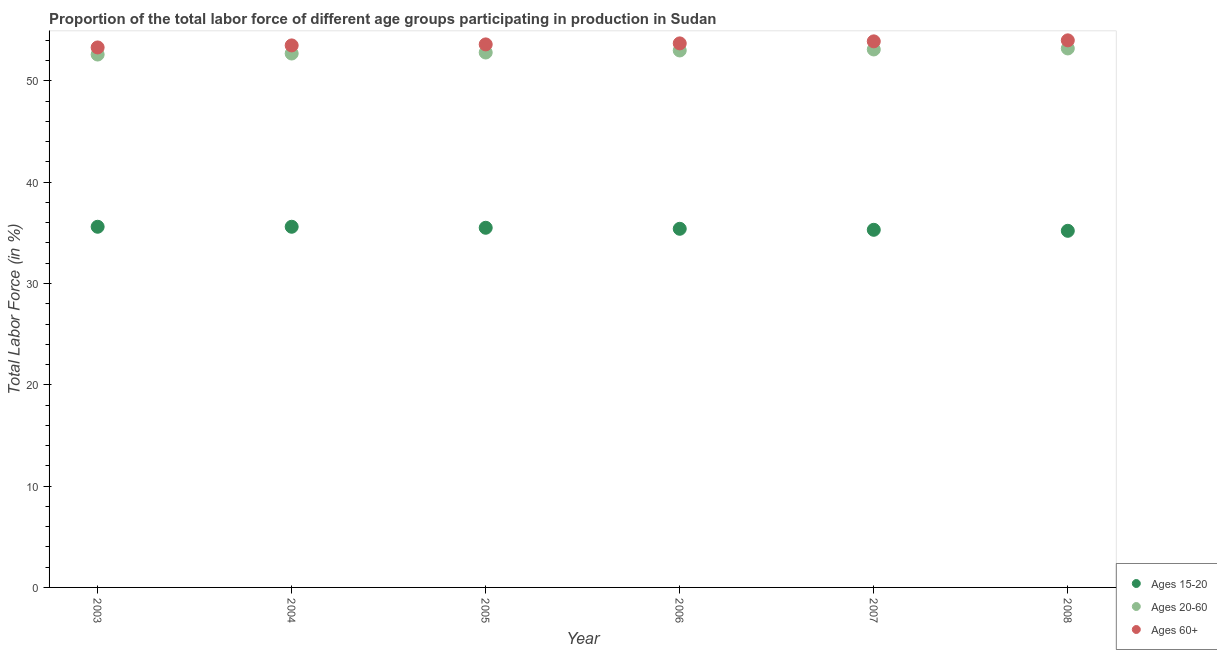Is the number of dotlines equal to the number of legend labels?
Your response must be concise. Yes. What is the percentage of labor force within the age group 15-20 in 2007?
Your answer should be compact. 35.3. Across all years, what is the maximum percentage of labor force within the age group 15-20?
Your answer should be compact. 35.6. Across all years, what is the minimum percentage of labor force above age 60?
Your answer should be very brief. 53.3. In which year was the percentage of labor force above age 60 maximum?
Give a very brief answer. 2008. What is the total percentage of labor force within the age group 20-60 in the graph?
Your response must be concise. 317.4. What is the difference between the percentage of labor force within the age group 15-20 in 2007 and that in 2008?
Make the answer very short. 0.1. What is the difference between the percentage of labor force within the age group 15-20 in 2003 and the percentage of labor force above age 60 in 2006?
Ensure brevity in your answer.  -18.1. What is the average percentage of labor force above age 60 per year?
Offer a terse response. 53.67. In the year 2008, what is the difference between the percentage of labor force above age 60 and percentage of labor force within the age group 15-20?
Offer a terse response. 18.8. In how many years, is the percentage of labor force above age 60 greater than 46 %?
Offer a very short reply. 6. What is the ratio of the percentage of labor force within the age group 15-20 in 2003 to that in 2006?
Give a very brief answer. 1.01. What is the difference between the highest and the second highest percentage of labor force within the age group 20-60?
Your answer should be very brief. 0.1. What is the difference between the highest and the lowest percentage of labor force within the age group 20-60?
Your answer should be very brief. 0.6. In how many years, is the percentage of labor force above age 60 greater than the average percentage of labor force above age 60 taken over all years?
Offer a terse response. 3. Does the percentage of labor force within the age group 15-20 monotonically increase over the years?
Your response must be concise. No. How many dotlines are there?
Keep it short and to the point. 3. How many years are there in the graph?
Your answer should be compact. 6. What is the difference between two consecutive major ticks on the Y-axis?
Offer a very short reply. 10. Are the values on the major ticks of Y-axis written in scientific E-notation?
Your answer should be compact. No. Where does the legend appear in the graph?
Give a very brief answer. Bottom right. What is the title of the graph?
Your answer should be compact. Proportion of the total labor force of different age groups participating in production in Sudan. What is the Total Labor Force (in %) of Ages 15-20 in 2003?
Offer a terse response. 35.6. What is the Total Labor Force (in %) in Ages 20-60 in 2003?
Ensure brevity in your answer.  52.6. What is the Total Labor Force (in %) of Ages 60+ in 2003?
Ensure brevity in your answer.  53.3. What is the Total Labor Force (in %) in Ages 15-20 in 2004?
Your response must be concise. 35.6. What is the Total Labor Force (in %) of Ages 20-60 in 2004?
Your answer should be compact. 52.7. What is the Total Labor Force (in %) of Ages 60+ in 2004?
Offer a very short reply. 53.5. What is the Total Labor Force (in %) in Ages 15-20 in 2005?
Provide a succinct answer. 35.5. What is the Total Labor Force (in %) of Ages 20-60 in 2005?
Give a very brief answer. 52.8. What is the Total Labor Force (in %) of Ages 60+ in 2005?
Keep it short and to the point. 53.6. What is the Total Labor Force (in %) of Ages 15-20 in 2006?
Keep it short and to the point. 35.4. What is the Total Labor Force (in %) of Ages 20-60 in 2006?
Ensure brevity in your answer.  53. What is the Total Labor Force (in %) in Ages 60+ in 2006?
Offer a very short reply. 53.7. What is the Total Labor Force (in %) of Ages 15-20 in 2007?
Your response must be concise. 35.3. What is the Total Labor Force (in %) of Ages 20-60 in 2007?
Offer a terse response. 53.1. What is the Total Labor Force (in %) of Ages 60+ in 2007?
Provide a short and direct response. 53.9. What is the Total Labor Force (in %) of Ages 15-20 in 2008?
Offer a terse response. 35.2. What is the Total Labor Force (in %) of Ages 20-60 in 2008?
Provide a succinct answer. 53.2. What is the Total Labor Force (in %) of Ages 60+ in 2008?
Give a very brief answer. 54. Across all years, what is the maximum Total Labor Force (in %) of Ages 15-20?
Ensure brevity in your answer.  35.6. Across all years, what is the maximum Total Labor Force (in %) in Ages 20-60?
Give a very brief answer. 53.2. Across all years, what is the minimum Total Labor Force (in %) in Ages 15-20?
Ensure brevity in your answer.  35.2. Across all years, what is the minimum Total Labor Force (in %) in Ages 20-60?
Keep it short and to the point. 52.6. Across all years, what is the minimum Total Labor Force (in %) in Ages 60+?
Make the answer very short. 53.3. What is the total Total Labor Force (in %) in Ages 15-20 in the graph?
Your answer should be very brief. 212.6. What is the total Total Labor Force (in %) of Ages 20-60 in the graph?
Keep it short and to the point. 317.4. What is the total Total Labor Force (in %) in Ages 60+ in the graph?
Offer a terse response. 322. What is the difference between the Total Labor Force (in %) in Ages 20-60 in 2003 and that in 2005?
Offer a terse response. -0.2. What is the difference between the Total Labor Force (in %) in Ages 60+ in 2003 and that in 2005?
Keep it short and to the point. -0.3. What is the difference between the Total Labor Force (in %) of Ages 15-20 in 2003 and that in 2006?
Offer a very short reply. 0.2. What is the difference between the Total Labor Force (in %) of Ages 15-20 in 2003 and that in 2007?
Provide a short and direct response. 0.3. What is the difference between the Total Labor Force (in %) in Ages 20-60 in 2003 and that in 2008?
Your response must be concise. -0.6. What is the difference between the Total Labor Force (in %) of Ages 15-20 in 2004 and that in 2005?
Offer a terse response. 0.1. What is the difference between the Total Labor Force (in %) in Ages 20-60 in 2004 and that in 2006?
Your response must be concise. -0.3. What is the difference between the Total Labor Force (in %) in Ages 60+ in 2004 and that in 2006?
Ensure brevity in your answer.  -0.2. What is the difference between the Total Labor Force (in %) of Ages 60+ in 2004 and that in 2007?
Give a very brief answer. -0.4. What is the difference between the Total Labor Force (in %) in Ages 60+ in 2004 and that in 2008?
Your answer should be compact. -0.5. What is the difference between the Total Labor Force (in %) of Ages 15-20 in 2005 and that in 2006?
Your response must be concise. 0.1. What is the difference between the Total Labor Force (in %) of Ages 20-60 in 2005 and that in 2006?
Provide a succinct answer. -0.2. What is the difference between the Total Labor Force (in %) in Ages 60+ in 2005 and that in 2006?
Ensure brevity in your answer.  -0.1. What is the difference between the Total Labor Force (in %) of Ages 15-20 in 2005 and that in 2007?
Provide a succinct answer. 0.2. What is the difference between the Total Labor Force (in %) of Ages 20-60 in 2005 and that in 2008?
Offer a terse response. -0.4. What is the difference between the Total Labor Force (in %) in Ages 60+ in 2005 and that in 2008?
Your answer should be very brief. -0.4. What is the difference between the Total Labor Force (in %) in Ages 20-60 in 2006 and that in 2007?
Offer a very short reply. -0.1. What is the difference between the Total Labor Force (in %) in Ages 60+ in 2006 and that in 2007?
Offer a terse response. -0.2. What is the difference between the Total Labor Force (in %) of Ages 20-60 in 2006 and that in 2008?
Give a very brief answer. -0.2. What is the difference between the Total Labor Force (in %) of Ages 60+ in 2006 and that in 2008?
Provide a succinct answer. -0.3. What is the difference between the Total Labor Force (in %) of Ages 20-60 in 2007 and that in 2008?
Offer a very short reply. -0.1. What is the difference between the Total Labor Force (in %) in Ages 60+ in 2007 and that in 2008?
Make the answer very short. -0.1. What is the difference between the Total Labor Force (in %) in Ages 15-20 in 2003 and the Total Labor Force (in %) in Ages 20-60 in 2004?
Ensure brevity in your answer.  -17.1. What is the difference between the Total Labor Force (in %) of Ages 15-20 in 2003 and the Total Labor Force (in %) of Ages 60+ in 2004?
Your answer should be compact. -17.9. What is the difference between the Total Labor Force (in %) of Ages 20-60 in 2003 and the Total Labor Force (in %) of Ages 60+ in 2004?
Your answer should be very brief. -0.9. What is the difference between the Total Labor Force (in %) in Ages 15-20 in 2003 and the Total Labor Force (in %) in Ages 20-60 in 2005?
Provide a short and direct response. -17.2. What is the difference between the Total Labor Force (in %) of Ages 15-20 in 2003 and the Total Labor Force (in %) of Ages 60+ in 2005?
Ensure brevity in your answer.  -18. What is the difference between the Total Labor Force (in %) of Ages 20-60 in 2003 and the Total Labor Force (in %) of Ages 60+ in 2005?
Your response must be concise. -1. What is the difference between the Total Labor Force (in %) of Ages 15-20 in 2003 and the Total Labor Force (in %) of Ages 20-60 in 2006?
Your answer should be very brief. -17.4. What is the difference between the Total Labor Force (in %) in Ages 15-20 in 2003 and the Total Labor Force (in %) in Ages 60+ in 2006?
Offer a terse response. -18.1. What is the difference between the Total Labor Force (in %) of Ages 15-20 in 2003 and the Total Labor Force (in %) of Ages 20-60 in 2007?
Ensure brevity in your answer.  -17.5. What is the difference between the Total Labor Force (in %) in Ages 15-20 in 2003 and the Total Labor Force (in %) in Ages 60+ in 2007?
Offer a very short reply. -18.3. What is the difference between the Total Labor Force (in %) of Ages 15-20 in 2003 and the Total Labor Force (in %) of Ages 20-60 in 2008?
Give a very brief answer. -17.6. What is the difference between the Total Labor Force (in %) in Ages 15-20 in 2003 and the Total Labor Force (in %) in Ages 60+ in 2008?
Provide a short and direct response. -18.4. What is the difference between the Total Labor Force (in %) of Ages 15-20 in 2004 and the Total Labor Force (in %) of Ages 20-60 in 2005?
Offer a very short reply. -17.2. What is the difference between the Total Labor Force (in %) of Ages 15-20 in 2004 and the Total Labor Force (in %) of Ages 60+ in 2005?
Your answer should be very brief. -18. What is the difference between the Total Labor Force (in %) of Ages 20-60 in 2004 and the Total Labor Force (in %) of Ages 60+ in 2005?
Offer a very short reply. -0.9. What is the difference between the Total Labor Force (in %) of Ages 15-20 in 2004 and the Total Labor Force (in %) of Ages 20-60 in 2006?
Offer a terse response. -17.4. What is the difference between the Total Labor Force (in %) in Ages 15-20 in 2004 and the Total Labor Force (in %) in Ages 60+ in 2006?
Keep it short and to the point. -18.1. What is the difference between the Total Labor Force (in %) in Ages 15-20 in 2004 and the Total Labor Force (in %) in Ages 20-60 in 2007?
Make the answer very short. -17.5. What is the difference between the Total Labor Force (in %) in Ages 15-20 in 2004 and the Total Labor Force (in %) in Ages 60+ in 2007?
Your answer should be compact. -18.3. What is the difference between the Total Labor Force (in %) of Ages 15-20 in 2004 and the Total Labor Force (in %) of Ages 20-60 in 2008?
Your response must be concise. -17.6. What is the difference between the Total Labor Force (in %) of Ages 15-20 in 2004 and the Total Labor Force (in %) of Ages 60+ in 2008?
Your answer should be very brief. -18.4. What is the difference between the Total Labor Force (in %) in Ages 20-60 in 2004 and the Total Labor Force (in %) in Ages 60+ in 2008?
Your answer should be compact. -1.3. What is the difference between the Total Labor Force (in %) of Ages 15-20 in 2005 and the Total Labor Force (in %) of Ages 20-60 in 2006?
Keep it short and to the point. -17.5. What is the difference between the Total Labor Force (in %) of Ages 15-20 in 2005 and the Total Labor Force (in %) of Ages 60+ in 2006?
Ensure brevity in your answer.  -18.2. What is the difference between the Total Labor Force (in %) of Ages 15-20 in 2005 and the Total Labor Force (in %) of Ages 20-60 in 2007?
Keep it short and to the point. -17.6. What is the difference between the Total Labor Force (in %) in Ages 15-20 in 2005 and the Total Labor Force (in %) in Ages 60+ in 2007?
Your answer should be very brief. -18.4. What is the difference between the Total Labor Force (in %) in Ages 20-60 in 2005 and the Total Labor Force (in %) in Ages 60+ in 2007?
Provide a short and direct response. -1.1. What is the difference between the Total Labor Force (in %) in Ages 15-20 in 2005 and the Total Labor Force (in %) in Ages 20-60 in 2008?
Provide a succinct answer. -17.7. What is the difference between the Total Labor Force (in %) in Ages 15-20 in 2005 and the Total Labor Force (in %) in Ages 60+ in 2008?
Ensure brevity in your answer.  -18.5. What is the difference between the Total Labor Force (in %) of Ages 15-20 in 2006 and the Total Labor Force (in %) of Ages 20-60 in 2007?
Your answer should be compact. -17.7. What is the difference between the Total Labor Force (in %) in Ages 15-20 in 2006 and the Total Labor Force (in %) in Ages 60+ in 2007?
Your answer should be very brief. -18.5. What is the difference between the Total Labor Force (in %) in Ages 20-60 in 2006 and the Total Labor Force (in %) in Ages 60+ in 2007?
Your answer should be compact. -0.9. What is the difference between the Total Labor Force (in %) of Ages 15-20 in 2006 and the Total Labor Force (in %) of Ages 20-60 in 2008?
Your answer should be very brief. -17.8. What is the difference between the Total Labor Force (in %) in Ages 15-20 in 2006 and the Total Labor Force (in %) in Ages 60+ in 2008?
Your answer should be very brief. -18.6. What is the difference between the Total Labor Force (in %) of Ages 15-20 in 2007 and the Total Labor Force (in %) of Ages 20-60 in 2008?
Offer a terse response. -17.9. What is the difference between the Total Labor Force (in %) of Ages 15-20 in 2007 and the Total Labor Force (in %) of Ages 60+ in 2008?
Provide a succinct answer. -18.7. What is the difference between the Total Labor Force (in %) in Ages 20-60 in 2007 and the Total Labor Force (in %) in Ages 60+ in 2008?
Your answer should be very brief. -0.9. What is the average Total Labor Force (in %) in Ages 15-20 per year?
Provide a succinct answer. 35.43. What is the average Total Labor Force (in %) in Ages 20-60 per year?
Your answer should be very brief. 52.9. What is the average Total Labor Force (in %) of Ages 60+ per year?
Provide a short and direct response. 53.67. In the year 2003, what is the difference between the Total Labor Force (in %) of Ages 15-20 and Total Labor Force (in %) of Ages 60+?
Provide a short and direct response. -17.7. In the year 2003, what is the difference between the Total Labor Force (in %) of Ages 20-60 and Total Labor Force (in %) of Ages 60+?
Ensure brevity in your answer.  -0.7. In the year 2004, what is the difference between the Total Labor Force (in %) in Ages 15-20 and Total Labor Force (in %) in Ages 20-60?
Provide a succinct answer. -17.1. In the year 2004, what is the difference between the Total Labor Force (in %) of Ages 15-20 and Total Labor Force (in %) of Ages 60+?
Your response must be concise. -17.9. In the year 2005, what is the difference between the Total Labor Force (in %) in Ages 15-20 and Total Labor Force (in %) in Ages 20-60?
Offer a very short reply. -17.3. In the year 2005, what is the difference between the Total Labor Force (in %) in Ages 15-20 and Total Labor Force (in %) in Ages 60+?
Your answer should be very brief. -18.1. In the year 2006, what is the difference between the Total Labor Force (in %) of Ages 15-20 and Total Labor Force (in %) of Ages 20-60?
Offer a very short reply. -17.6. In the year 2006, what is the difference between the Total Labor Force (in %) in Ages 15-20 and Total Labor Force (in %) in Ages 60+?
Your answer should be compact. -18.3. In the year 2006, what is the difference between the Total Labor Force (in %) in Ages 20-60 and Total Labor Force (in %) in Ages 60+?
Provide a short and direct response. -0.7. In the year 2007, what is the difference between the Total Labor Force (in %) in Ages 15-20 and Total Labor Force (in %) in Ages 20-60?
Provide a short and direct response. -17.8. In the year 2007, what is the difference between the Total Labor Force (in %) in Ages 15-20 and Total Labor Force (in %) in Ages 60+?
Keep it short and to the point. -18.6. In the year 2007, what is the difference between the Total Labor Force (in %) in Ages 20-60 and Total Labor Force (in %) in Ages 60+?
Your answer should be compact. -0.8. In the year 2008, what is the difference between the Total Labor Force (in %) in Ages 15-20 and Total Labor Force (in %) in Ages 20-60?
Make the answer very short. -18. In the year 2008, what is the difference between the Total Labor Force (in %) of Ages 15-20 and Total Labor Force (in %) of Ages 60+?
Your response must be concise. -18.8. In the year 2008, what is the difference between the Total Labor Force (in %) of Ages 20-60 and Total Labor Force (in %) of Ages 60+?
Offer a very short reply. -0.8. What is the ratio of the Total Labor Force (in %) of Ages 20-60 in 2003 to that in 2004?
Provide a succinct answer. 1. What is the ratio of the Total Labor Force (in %) of Ages 60+ in 2003 to that in 2004?
Keep it short and to the point. 1. What is the ratio of the Total Labor Force (in %) of Ages 15-20 in 2003 to that in 2005?
Your response must be concise. 1. What is the ratio of the Total Labor Force (in %) of Ages 20-60 in 2003 to that in 2005?
Give a very brief answer. 1. What is the ratio of the Total Labor Force (in %) in Ages 60+ in 2003 to that in 2005?
Your response must be concise. 0.99. What is the ratio of the Total Labor Force (in %) in Ages 15-20 in 2003 to that in 2006?
Offer a terse response. 1.01. What is the ratio of the Total Labor Force (in %) of Ages 20-60 in 2003 to that in 2006?
Offer a very short reply. 0.99. What is the ratio of the Total Labor Force (in %) of Ages 15-20 in 2003 to that in 2007?
Ensure brevity in your answer.  1.01. What is the ratio of the Total Labor Force (in %) of Ages 20-60 in 2003 to that in 2007?
Provide a short and direct response. 0.99. What is the ratio of the Total Labor Force (in %) of Ages 60+ in 2003 to that in 2007?
Give a very brief answer. 0.99. What is the ratio of the Total Labor Force (in %) of Ages 15-20 in 2003 to that in 2008?
Ensure brevity in your answer.  1.01. What is the ratio of the Total Labor Force (in %) of Ages 20-60 in 2003 to that in 2008?
Give a very brief answer. 0.99. What is the ratio of the Total Labor Force (in %) of Ages 60+ in 2003 to that in 2008?
Offer a terse response. 0.99. What is the ratio of the Total Labor Force (in %) of Ages 15-20 in 2004 to that in 2005?
Offer a very short reply. 1. What is the ratio of the Total Labor Force (in %) in Ages 20-60 in 2004 to that in 2005?
Make the answer very short. 1. What is the ratio of the Total Labor Force (in %) of Ages 15-20 in 2004 to that in 2006?
Make the answer very short. 1.01. What is the ratio of the Total Labor Force (in %) of Ages 20-60 in 2004 to that in 2006?
Provide a succinct answer. 0.99. What is the ratio of the Total Labor Force (in %) in Ages 60+ in 2004 to that in 2006?
Ensure brevity in your answer.  1. What is the ratio of the Total Labor Force (in %) in Ages 15-20 in 2004 to that in 2007?
Provide a short and direct response. 1.01. What is the ratio of the Total Labor Force (in %) of Ages 20-60 in 2004 to that in 2007?
Ensure brevity in your answer.  0.99. What is the ratio of the Total Labor Force (in %) in Ages 60+ in 2004 to that in 2007?
Your response must be concise. 0.99. What is the ratio of the Total Labor Force (in %) in Ages 15-20 in 2004 to that in 2008?
Offer a very short reply. 1.01. What is the ratio of the Total Labor Force (in %) of Ages 20-60 in 2004 to that in 2008?
Give a very brief answer. 0.99. What is the ratio of the Total Labor Force (in %) of Ages 60+ in 2004 to that in 2008?
Offer a terse response. 0.99. What is the ratio of the Total Labor Force (in %) of Ages 15-20 in 2005 to that in 2006?
Make the answer very short. 1. What is the ratio of the Total Labor Force (in %) of Ages 20-60 in 2005 to that in 2006?
Provide a succinct answer. 1. What is the ratio of the Total Labor Force (in %) in Ages 60+ in 2005 to that in 2006?
Provide a short and direct response. 1. What is the ratio of the Total Labor Force (in %) in Ages 15-20 in 2005 to that in 2007?
Provide a short and direct response. 1.01. What is the ratio of the Total Labor Force (in %) of Ages 20-60 in 2005 to that in 2007?
Offer a very short reply. 0.99. What is the ratio of the Total Labor Force (in %) in Ages 15-20 in 2005 to that in 2008?
Ensure brevity in your answer.  1.01. What is the ratio of the Total Labor Force (in %) of Ages 20-60 in 2005 to that in 2008?
Your answer should be very brief. 0.99. What is the ratio of the Total Labor Force (in %) of Ages 60+ in 2006 to that in 2007?
Offer a very short reply. 1. What is the ratio of the Total Labor Force (in %) of Ages 60+ in 2006 to that in 2008?
Keep it short and to the point. 0.99. What is the ratio of the Total Labor Force (in %) of Ages 15-20 in 2007 to that in 2008?
Your answer should be compact. 1. What is the difference between the highest and the second highest Total Labor Force (in %) in Ages 15-20?
Your response must be concise. 0. What is the difference between the highest and the second highest Total Labor Force (in %) in Ages 60+?
Make the answer very short. 0.1. What is the difference between the highest and the lowest Total Labor Force (in %) in Ages 15-20?
Ensure brevity in your answer.  0.4. What is the difference between the highest and the lowest Total Labor Force (in %) of Ages 20-60?
Provide a short and direct response. 0.6. What is the difference between the highest and the lowest Total Labor Force (in %) in Ages 60+?
Give a very brief answer. 0.7. 